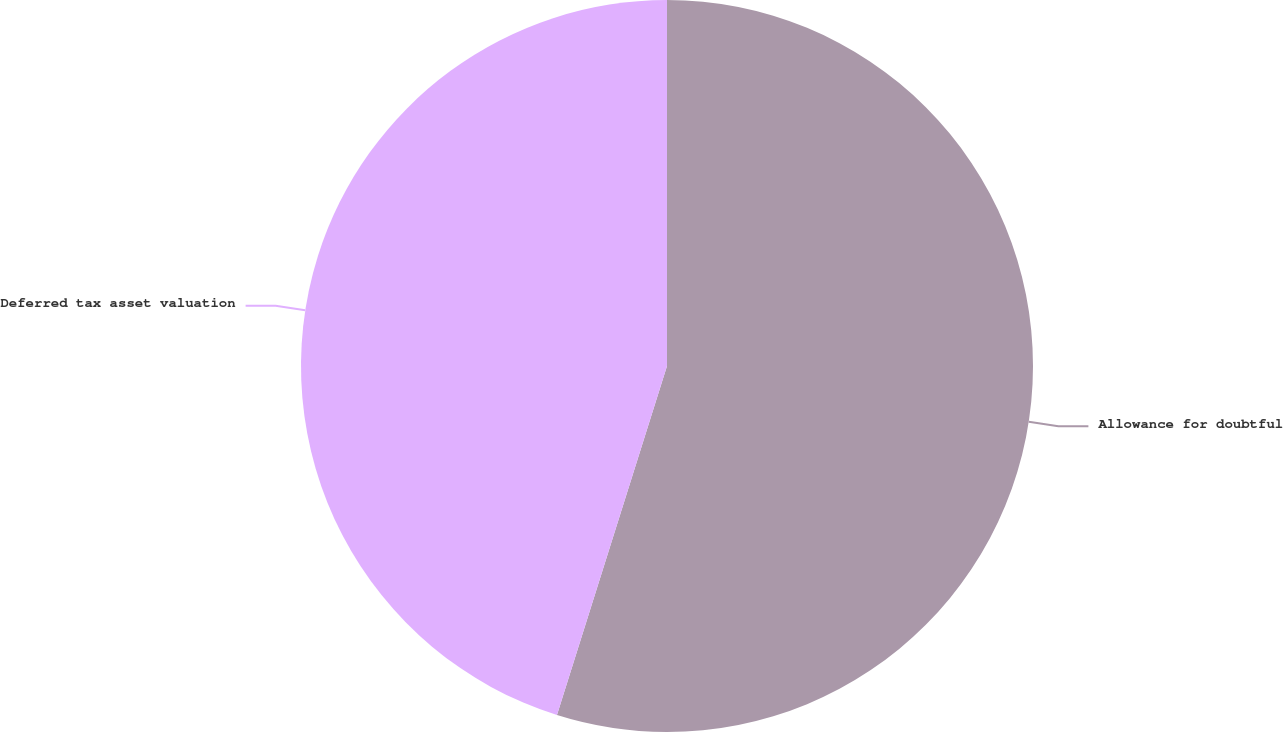Convert chart. <chart><loc_0><loc_0><loc_500><loc_500><pie_chart><fcel>Allowance for doubtful<fcel>Deferred tax asset valuation<nl><fcel>54.86%<fcel>45.14%<nl></chart> 